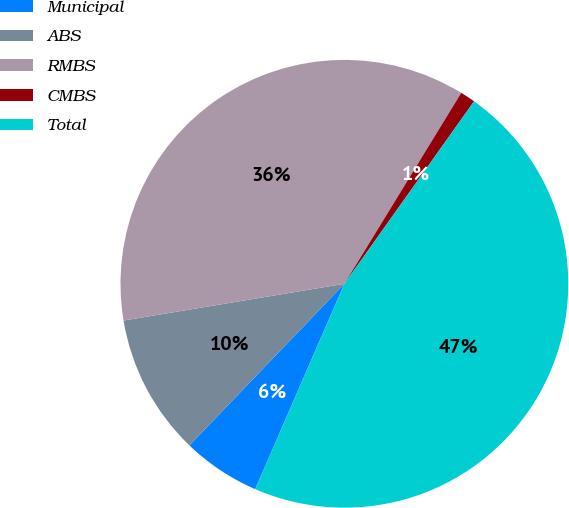Convert chart. <chart><loc_0><loc_0><loc_500><loc_500><pie_chart><fcel>Municipal<fcel>ABS<fcel>RMBS<fcel>CMBS<fcel>Total<nl><fcel>5.65%<fcel>10.21%<fcel>36.37%<fcel>1.09%<fcel>46.69%<nl></chart> 